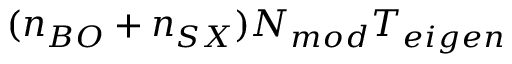Convert formula to latex. <formula><loc_0><loc_0><loc_500><loc_500>( n _ { B O } + n _ { S X } ) N _ { m o d } T _ { e i g e n }</formula> 